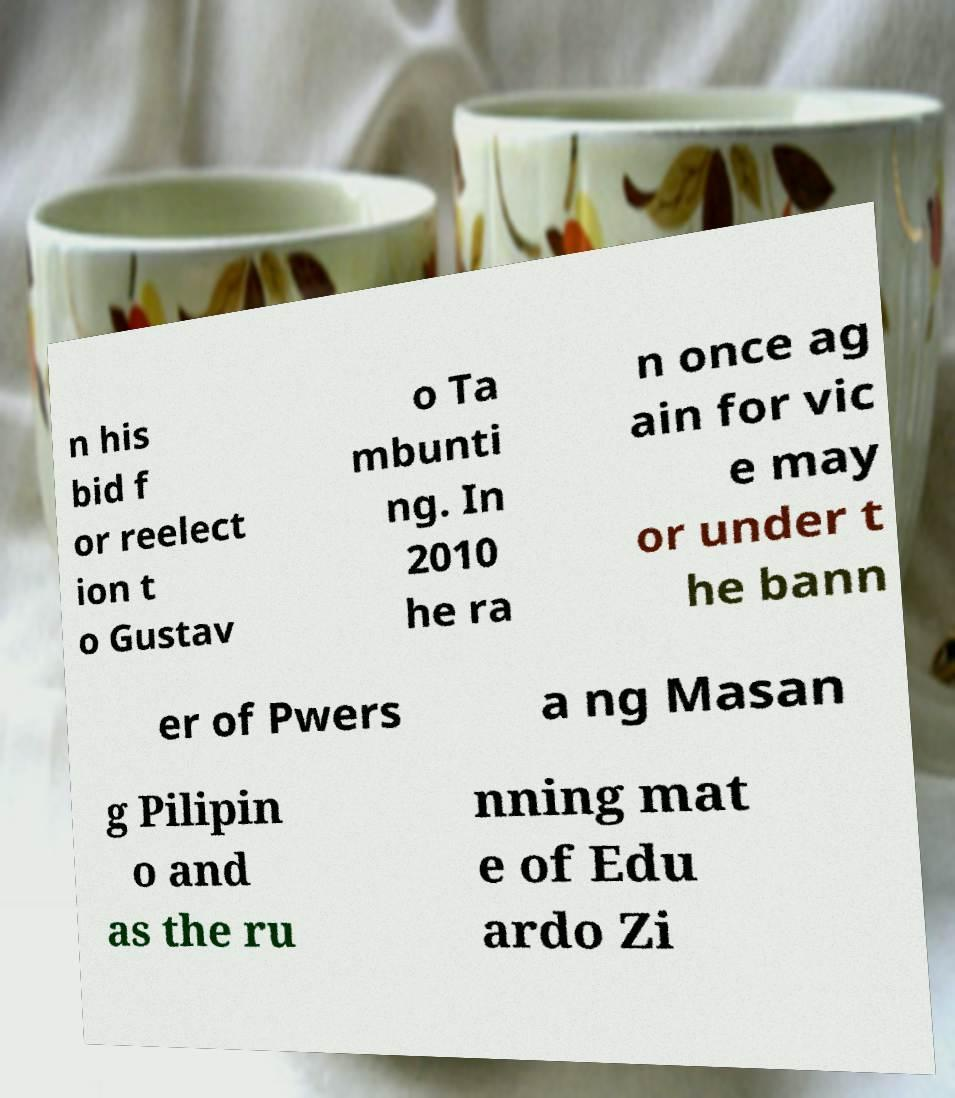Please read and relay the text visible in this image. What does it say? n his bid f or reelect ion t o Gustav o Ta mbunti ng. In 2010 he ra n once ag ain for vic e may or under t he bann er of Pwers a ng Masan g Pilipin o and as the ru nning mat e of Edu ardo Zi 